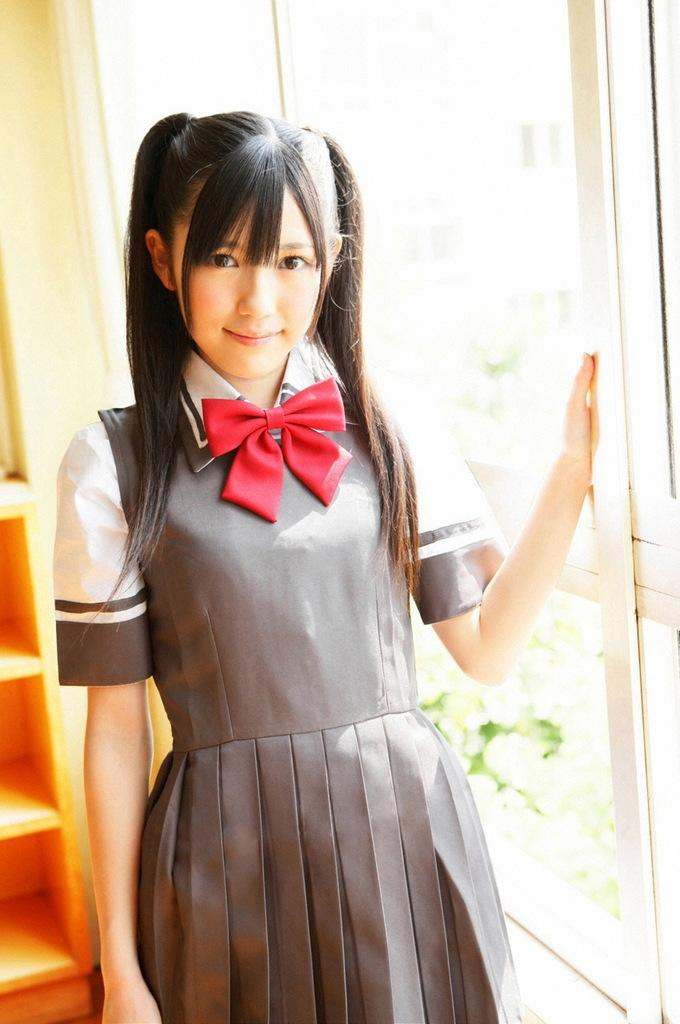Who is the main subject in the image? There is a girl in the middle of the image. What can be seen in the background of the image? There are shelves in the background of the image. What is the girl doing in the image? The girl is holding the window. What type of clothing is the girl wearing? The girl is wearing a uniform. What fact did the writer discover about the girl's death in the image? There is no mention of death or a writer in the image, so this question cannot be answered. 